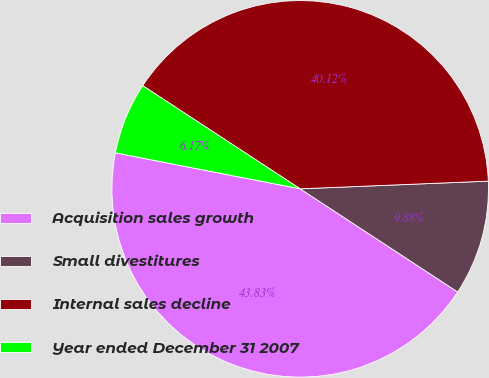Convert chart. <chart><loc_0><loc_0><loc_500><loc_500><pie_chart><fcel>Acquisition sales growth<fcel>Small divestitures<fcel>Internal sales decline<fcel>Year ended December 31 2007<nl><fcel>43.83%<fcel>9.88%<fcel>40.12%<fcel>6.17%<nl></chart> 